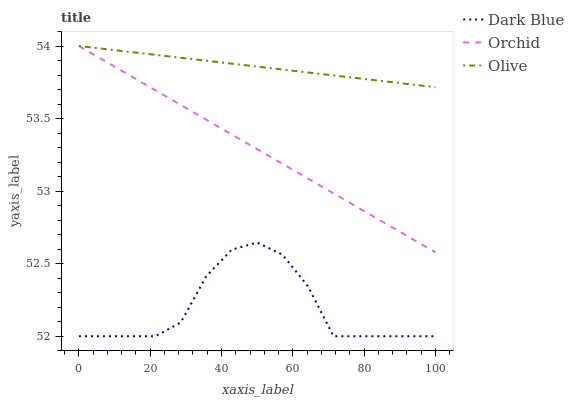Does Dark Blue have the minimum area under the curve?
Answer yes or no. Yes. Does Olive have the maximum area under the curve?
Answer yes or no. Yes. Does Orchid have the minimum area under the curve?
Answer yes or no. No. Does Orchid have the maximum area under the curve?
Answer yes or no. No. Is Orchid the smoothest?
Answer yes or no. Yes. Is Dark Blue the roughest?
Answer yes or no. Yes. Is Dark Blue the smoothest?
Answer yes or no. No. Is Orchid the roughest?
Answer yes or no. No. Does Dark Blue have the lowest value?
Answer yes or no. Yes. Does Orchid have the lowest value?
Answer yes or no. No. Does Orchid have the highest value?
Answer yes or no. Yes. Does Dark Blue have the highest value?
Answer yes or no. No. Is Dark Blue less than Olive?
Answer yes or no. Yes. Is Olive greater than Dark Blue?
Answer yes or no. Yes. Does Orchid intersect Olive?
Answer yes or no. Yes. Is Orchid less than Olive?
Answer yes or no. No. Is Orchid greater than Olive?
Answer yes or no. No. Does Dark Blue intersect Olive?
Answer yes or no. No. 